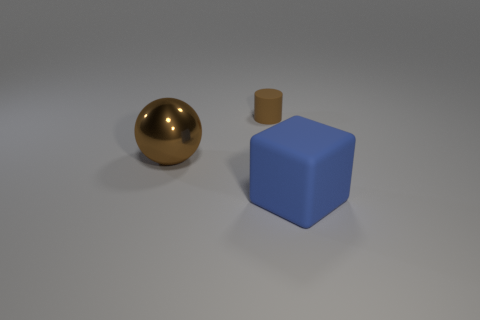Add 1 small brown matte cylinders. How many objects exist? 4 Subtract all cubes. How many objects are left? 2 Subtract 1 cylinders. How many cylinders are left? 0 Subtract 1 brown balls. How many objects are left? 2 Subtract all red spheres. Subtract all purple cylinders. How many spheres are left? 1 Subtract all brown spheres. How many red cylinders are left? 0 Subtract all big blue matte blocks. Subtract all rubber blocks. How many objects are left? 1 Add 1 big shiny spheres. How many big shiny spheres are left? 2 Add 2 red metal blocks. How many red metal blocks exist? 2 